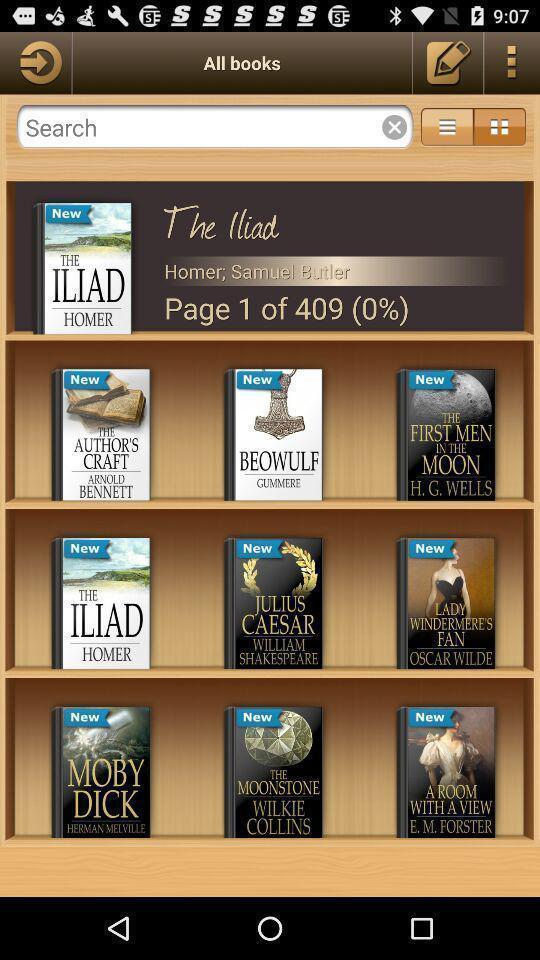Tell me about the visual elements in this screen capture. Screen displaying the various books. 